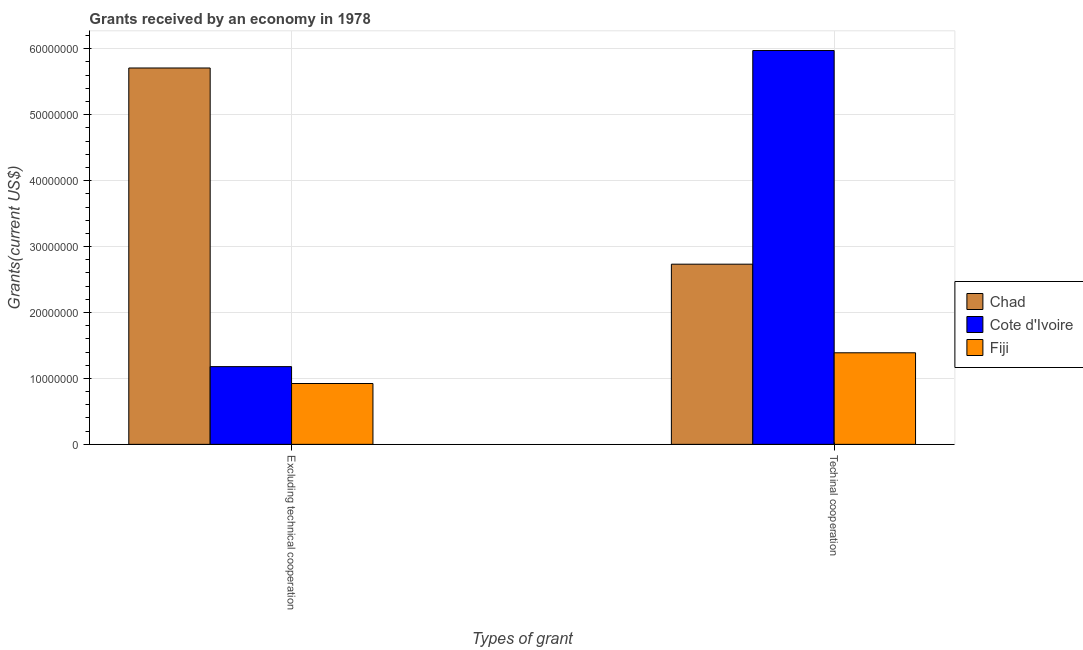How many different coloured bars are there?
Keep it short and to the point. 3. How many groups of bars are there?
Keep it short and to the point. 2. Are the number of bars on each tick of the X-axis equal?
Ensure brevity in your answer.  Yes. How many bars are there on the 1st tick from the right?
Your response must be concise. 3. What is the label of the 1st group of bars from the left?
Your answer should be compact. Excluding technical cooperation. What is the amount of grants received(excluding technical cooperation) in Cote d'Ivoire?
Provide a succinct answer. 1.18e+07. Across all countries, what is the maximum amount of grants received(including technical cooperation)?
Give a very brief answer. 5.97e+07. Across all countries, what is the minimum amount of grants received(including technical cooperation)?
Your answer should be very brief. 1.39e+07. In which country was the amount of grants received(including technical cooperation) maximum?
Your answer should be compact. Cote d'Ivoire. In which country was the amount of grants received(including technical cooperation) minimum?
Your answer should be very brief. Fiji. What is the total amount of grants received(including technical cooperation) in the graph?
Offer a very short reply. 1.01e+08. What is the difference between the amount of grants received(excluding technical cooperation) in Fiji and that in Chad?
Your answer should be very brief. -4.79e+07. What is the difference between the amount of grants received(excluding technical cooperation) in Fiji and the amount of grants received(including technical cooperation) in Chad?
Ensure brevity in your answer.  -1.81e+07. What is the average amount of grants received(including technical cooperation) per country?
Make the answer very short. 3.37e+07. What is the difference between the amount of grants received(including technical cooperation) and amount of grants received(excluding technical cooperation) in Fiji?
Keep it short and to the point. 4.66e+06. In how many countries, is the amount of grants received(including technical cooperation) greater than 14000000 US$?
Offer a terse response. 2. What is the ratio of the amount of grants received(excluding technical cooperation) in Chad to that in Cote d'Ivoire?
Your answer should be compact. 4.84. Is the amount of grants received(including technical cooperation) in Fiji less than that in Chad?
Give a very brief answer. Yes. What does the 2nd bar from the left in Techinal cooperation represents?
Offer a very short reply. Cote d'Ivoire. What does the 3rd bar from the right in Excluding technical cooperation represents?
Keep it short and to the point. Chad. How many bars are there?
Offer a terse response. 6. How many countries are there in the graph?
Provide a succinct answer. 3. Where does the legend appear in the graph?
Your answer should be compact. Center right. How are the legend labels stacked?
Make the answer very short. Vertical. What is the title of the graph?
Your answer should be very brief. Grants received by an economy in 1978. Does "Russian Federation" appear as one of the legend labels in the graph?
Your answer should be compact. No. What is the label or title of the X-axis?
Keep it short and to the point. Types of grant. What is the label or title of the Y-axis?
Your answer should be compact. Grants(current US$). What is the Grants(current US$) of Chad in Excluding technical cooperation?
Keep it short and to the point. 5.71e+07. What is the Grants(current US$) of Cote d'Ivoire in Excluding technical cooperation?
Provide a short and direct response. 1.18e+07. What is the Grants(current US$) in Fiji in Excluding technical cooperation?
Offer a very short reply. 9.23e+06. What is the Grants(current US$) of Chad in Techinal cooperation?
Ensure brevity in your answer.  2.73e+07. What is the Grants(current US$) of Cote d'Ivoire in Techinal cooperation?
Keep it short and to the point. 5.97e+07. What is the Grants(current US$) in Fiji in Techinal cooperation?
Ensure brevity in your answer.  1.39e+07. Across all Types of grant, what is the maximum Grants(current US$) in Chad?
Offer a terse response. 5.71e+07. Across all Types of grant, what is the maximum Grants(current US$) in Cote d'Ivoire?
Your response must be concise. 5.97e+07. Across all Types of grant, what is the maximum Grants(current US$) in Fiji?
Make the answer very short. 1.39e+07. Across all Types of grant, what is the minimum Grants(current US$) of Chad?
Ensure brevity in your answer.  2.73e+07. Across all Types of grant, what is the minimum Grants(current US$) in Cote d'Ivoire?
Your answer should be very brief. 1.18e+07. Across all Types of grant, what is the minimum Grants(current US$) of Fiji?
Provide a short and direct response. 9.23e+06. What is the total Grants(current US$) of Chad in the graph?
Provide a succinct answer. 8.44e+07. What is the total Grants(current US$) of Cote d'Ivoire in the graph?
Give a very brief answer. 7.15e+07. What is the total Grants(current US$) in Fiji in the graph?
Your response must be concise. 2.31e+07. What is the difference between the Grants(current US$) in Chad in Excluding technical cooperation and that in Techinal cooperation?
Provide a short and direct response. 2.98e+07. What is the difference between the Grants(current US$) in Cote d'Ivoire in Excluding technical cooperation and that in Techinal cooperation?
Your answer should be compact. -4.80e+07. What is the difference between the Grants(current US$) in Fiji in Excluding technical cooperation and that in Techinal cooperation?
Make the answer very short. -4.66e+06. What is the difference between the Grants(current US$) of Chad in Excluding technical cooperation and the Grants(current US$) of Cote d'Ivoire in Techinal cooperation?
Provide a succinct answer. -2.65e+06. What is the difference between the Grants(current US$) in Chad in Excluding technical cooperation and the Grants(current US$) in Fiji in Techinal cooperation?
Your answer should be very brief. 4.32e+07. What is the difference between the Grants(current US$) in Cote d'Ivoire in Excluding technical cooperation and the Grants(current US$) in Fiji in Techinal cooperation?
Your answer should be compact. -2.10e+06. What is the average Grants(current US$) of Chad per Types of grant?
Ensure brevity in your answer.  4.22e+07. What is the average Grants(current US$) in Cote d'Ivoire per Types of grant?
Ensure brevity in your answer.  3.58e+07. What is the average Grants(current US$) in Fiji per Types of grant?
Your response must be concise. 1.16e+07. What is the difference between the Grants(current US$) in Chad and Grants(current US$) in Cote d'Ivoire in Excluding technical cooperation?
Your answer should be very brief. 4.53e+07. What is the difference between the Grants(current US$) in Chad and Grants(current US$) in Fiji in Excluding technical cooperation?
Your answer should be compact. 4.79e+07. What is the difference between the Grants(current US$) of Cote d'Ivoire and Grants(current US$) of Fiji in Excluding technical cooperation?
Ensure brevity in your answer.  2.56e+06. What is the difference between the Grants(current US$) in Chad and Grants(current US$) in Cote d'Ivoire in Techinal cooperation?
Offer a terse response. -3.24e+07. What is the difference between the Grants(current US$) in Chad and Grants(current US$) in Fiji in Techinal cooperation?
Make the answer very short. 1.34e+07. What is the difference between the Grants(current US$) in Cote d'Ivoire and Grants(current US$) in Fiji in Techinal cooperation?
Your answer should be very brief. 4.58e+07. What is the ratio of the Grants(current US$) in Chad in Excluding technical cooperation to that in Techinal cooperation?
Your answer should be compact. 2.09. What is the ratio of the Grants(current US$) in Cote d'Ivoire in Excluding technical cooperation to that in Techinal cooperation?
Your answer should be compact. 0.2. What is the ratio of the Grants(current US$) of Fiji in Excluding technical cooperation to that in Techinal cooperation?
Your answer should be very brief. 0.66. What is the difference between the highest and the second highest Grants(current US$) of Chad?
Ensure brevity in your answer.  2.98e+07. What is the difference between the highest and the second highest Grants(current US$) in Cote d'Ivoire?
Give a very brief answer. 4.80e+07. What is the difference between the highest and the second highest Grants(current US$) of Fiji?
Ensure brevity in your answer.  4.66e+06. What is the difference between the highest and the lowest Grants(current US$) in Chad?
Your response must be concise. 2.98e+07. What is the difference between the highest and the lowest Grants(current US$) in Cote d'Ivoire?
Offer a terse response. 4.80e+07. What is the difference between the highest and the lowest Grants(current US$) in Fiji?
Provide a short and direct response. 4.66e+06. 